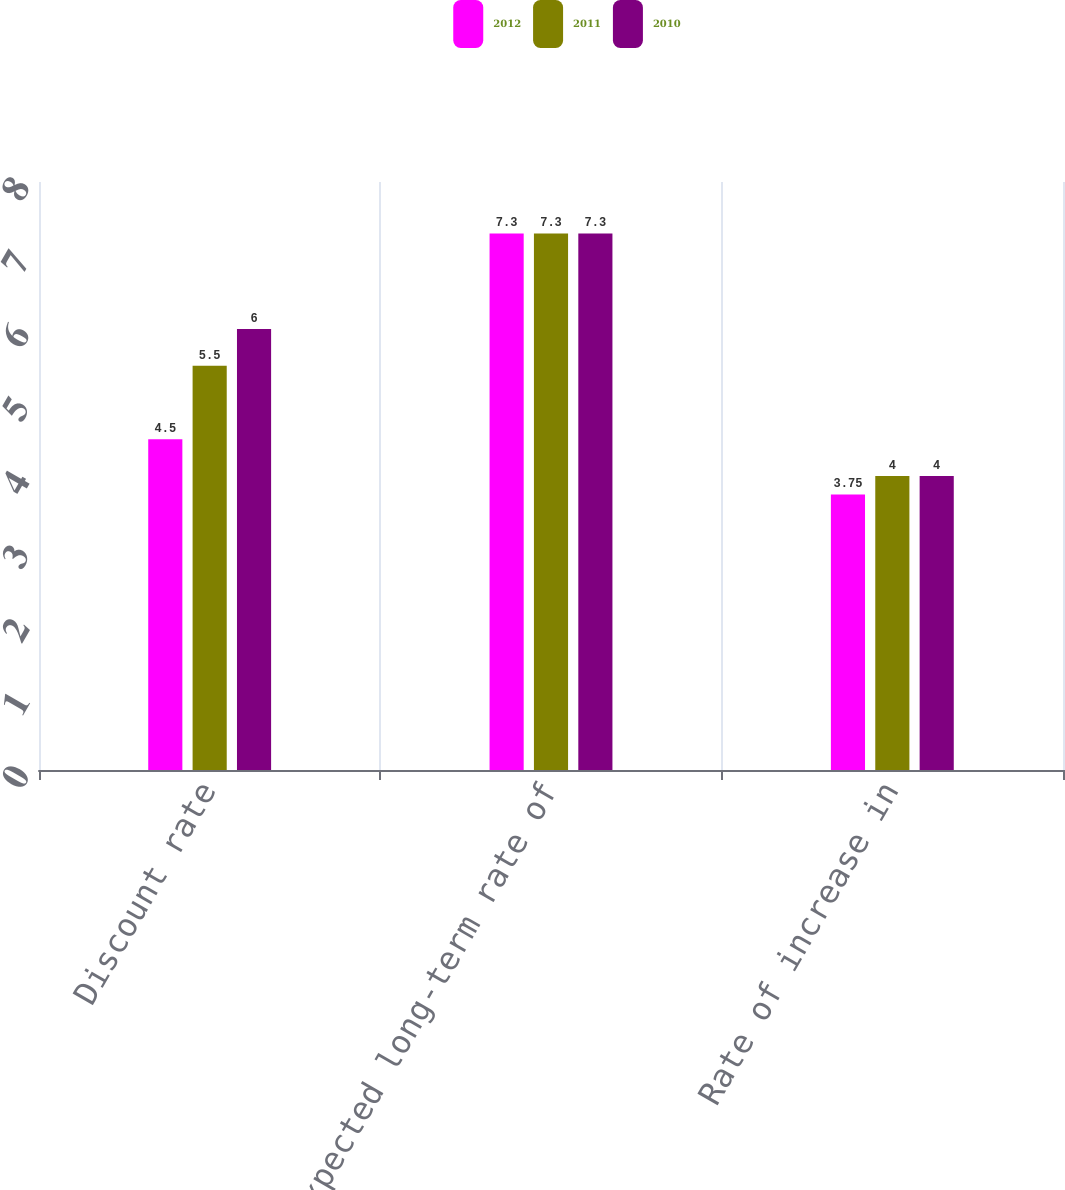Convert chart to OTSL. <chart><loc_0><loc_0><loc_500><loc_500><stacked_bar_chart><ecel><fcel>Discount rate<fcel>Expected long-term rate of<fcel>Rate of increase in<nl><fcel>2012<fcel>4.5<fcel>7.3<fcel>3.75<nl><fcel>2011<fcel>5.5<fcel>7.3<fcel>4<nl><fcel>2010<fcel>6<fcel>7.3<fcel>4<nl></chart> 